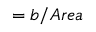Convert formula to latex. <formula><loc_0><loc_0><loc_500><loc_500>= { b } / { A r e a }</formula> 